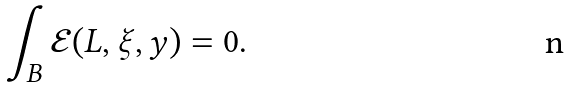Convert formula to latex. <formula><loc_0><loc_0><loc_500><loc_500>\int _ { B } \mathcal { E } ( L , \xi , y ) = 0 .</formula> 